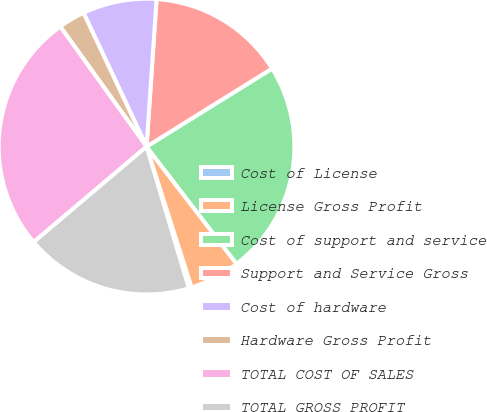Convert chart. <chart><loc_0><loc_0><loc_500><loc_500><pie_chart><fcel>Cost of License<fcel>License Gross Profit<fcel>Cost of support and service<fcel>Support and Service Gross<fcel>Cost of hardware<fcel>Hardware Gross Profit<fcel>TOTAL COST OF SALES<fcel>TOTAL GROSS PROFIT<nl><fcel>0.31%<fcel>5.5%<fcel>23.43%<fcel>15.07%<fcel>8.09%<fcel>2.91%<fcel>26.26%<fcel>18.44%<nl></chart> 